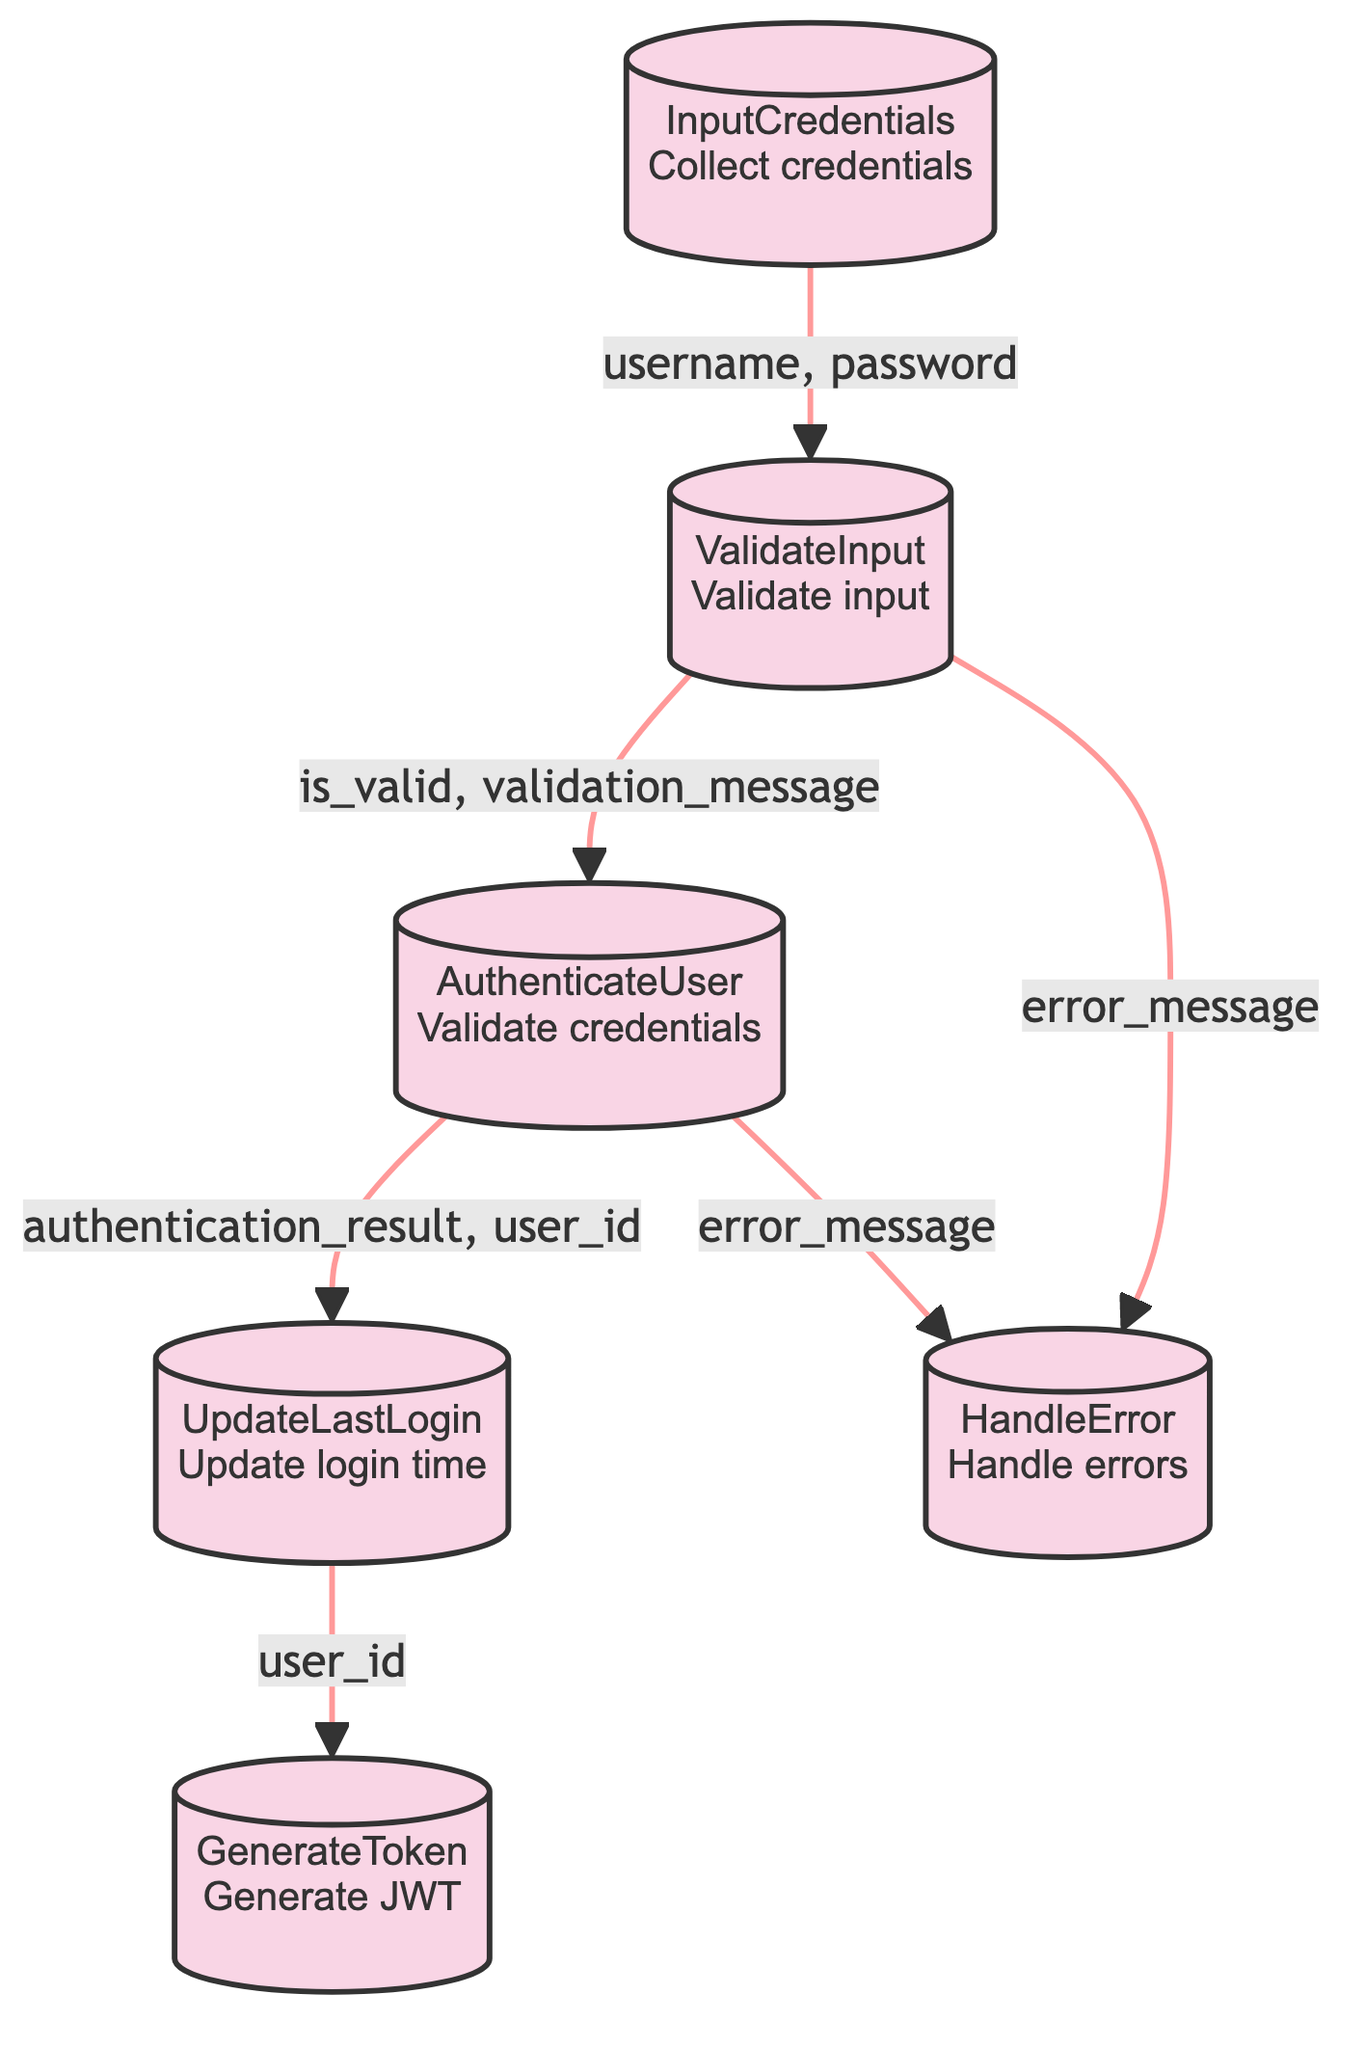What is the first function in the flowchart? The first function at the bottom of the flowchart is "InputCredentials," indicating that the process starts by collecting the user's credentials.
Answer: InputCredentials How many total functions are in the diagram? Counting all the distinct functions listed in the diagram, there are a total of six functions depicted.
Answer: Six What does the "ValidateInput" function output? The "ValidateInput" function has outputs for "is_valid" and "validation_message," indicating the results of the validation check.
Answer: is_valid, validation_message What happens if the user's credentials are invalid? If the user's credentials are invalid, the process will flow from the "AuthenticateUser" function to the "HandleError" function, indicating that an error response is generated.
Answer: HandleError What function is responsible for generating the JWT token? The "GenerateToken" function is designated to generate the JWT token once the user authentication is confirmed as successful.
Answer: GenerateToken If the input credentials are valid, which function is called next? If the input credentials are deemed valid, the flow proceeds from "ValidateInput" to the "AuthenticateUser" function for further verification of credentials.
Answer: AuthenticateUser Which function updates the user's last login timestamp? The "UpdateLastLogin" function is tasked with updating the user's last login timestamp in the database after authentication succeeds.
Answer: UpdateLastLogin What is processed after successful authentication? Following successful authentication, the "UpdateLastLogin" function is processed, then flows into the "GenerateToken" function, which creates a JWT token for the authenticated user.
Answer: GenerateToken What can cause an error response to be generated? An error response can be generated if either the "ValidateInput" checks fail leading to the "HandleError" function or if "AuthenticateUser" does not validate the credentials successfully triggering the same error handling.
Answer: HandleError 